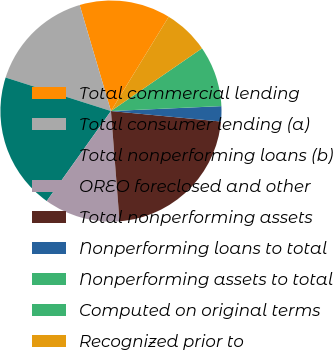Convert chart to OTSL. <chart><loc_0><loc_0><loc_500><loc_500><pie_chart><fcel>Total commercial lending<fcel>Total consumer lending (a)<fcel>Total nonperforming loans (b)<fcel>OREO foreclosed and other<fcel>Total nonperforming assets<fcel>Nonperforming loans to total<fcel>Nonperforming assets to total<fcel>Computed on original terms<fcel>Recognized prior to<nl><fcel>13.31%<fcel>15.53%<fcel>20.04%<fcel>11.1%<fcel>22.25%<fcel>2.22%<fcel>0.01%<fcel>8.88%<fcel>6.66%<nl></chart> 